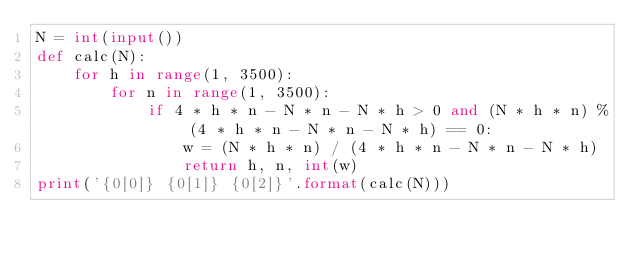Convert code to text. <code><loc_0><loc_0><loc_500><loc_500><_Python_>N = int(input())
def calc(N):
    for h in range(1, 3500):
        for n in range(1, 3500):
            if 4 * h * n - N * n - N * h > 0 and (N * h * n) % (4 * h * n - N * n - N * h) == 0:
                w = (N * h * n) / (4 * h * n - N * n - N * h)
                return h, n, int(w)
print('{0[0]} {0[1]} {0[2]}'.format(calc(N)))</code> 